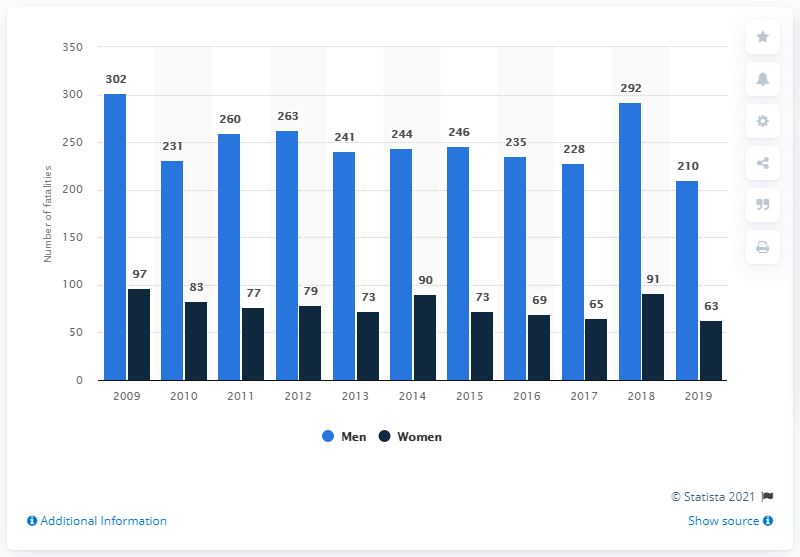List a handful of essential elements in this visual. In 2019, 210 men lost their lives in traffic accidents in Sweden. 